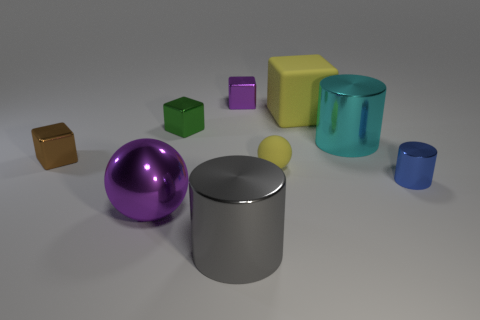Subtract all large metal cylinders. How many cylinders are left? 1 Subtract all balls. How many objects are left? 7 Subtract all purple cubes. How many cubes are left? 3 Subtract 1 cubes. How many cubes are left? 3 Add 5 small green metallic objects. How many small green metallic objects are left? 6 Add 6 brown metallic objects. How many brown metallic objects exist? 7 Subtract 0 green cylinders. How many objects are left? 9 Subtract all gray balls. Subtract all purple cubes. How many balls are left? 2 Subtract all balls. Subtract all red balls. How many objects are left? 7 